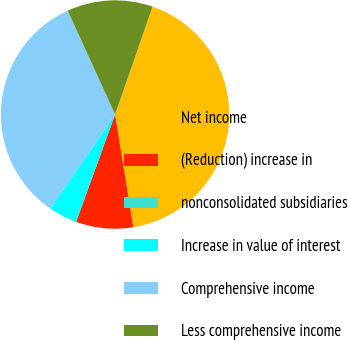<chart> <loc_0><loc_0><loc_500><loc_500><pie_chart><fcel>Net income<fcel>(Reduction) increase in<fcel>nonconsolidated subsidiaries<fcel>Increase in value of interest<fcel>Comprehensive income<fcel>Less comprehensive income<nl><fcel>42.13%<fcel>8.09%<fcel>0.02%<fcel>4.05%<fcel>33.57%<fcel>12.13%<nl></chart> 